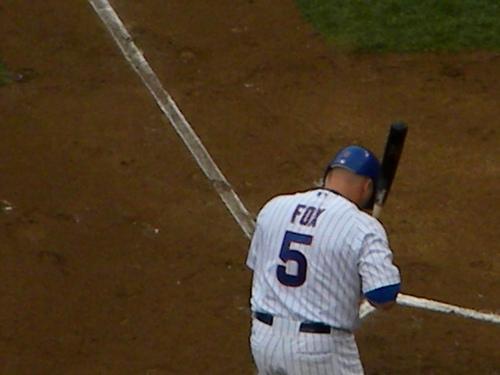How many people are shown?
Give a very brief answer. 1. 